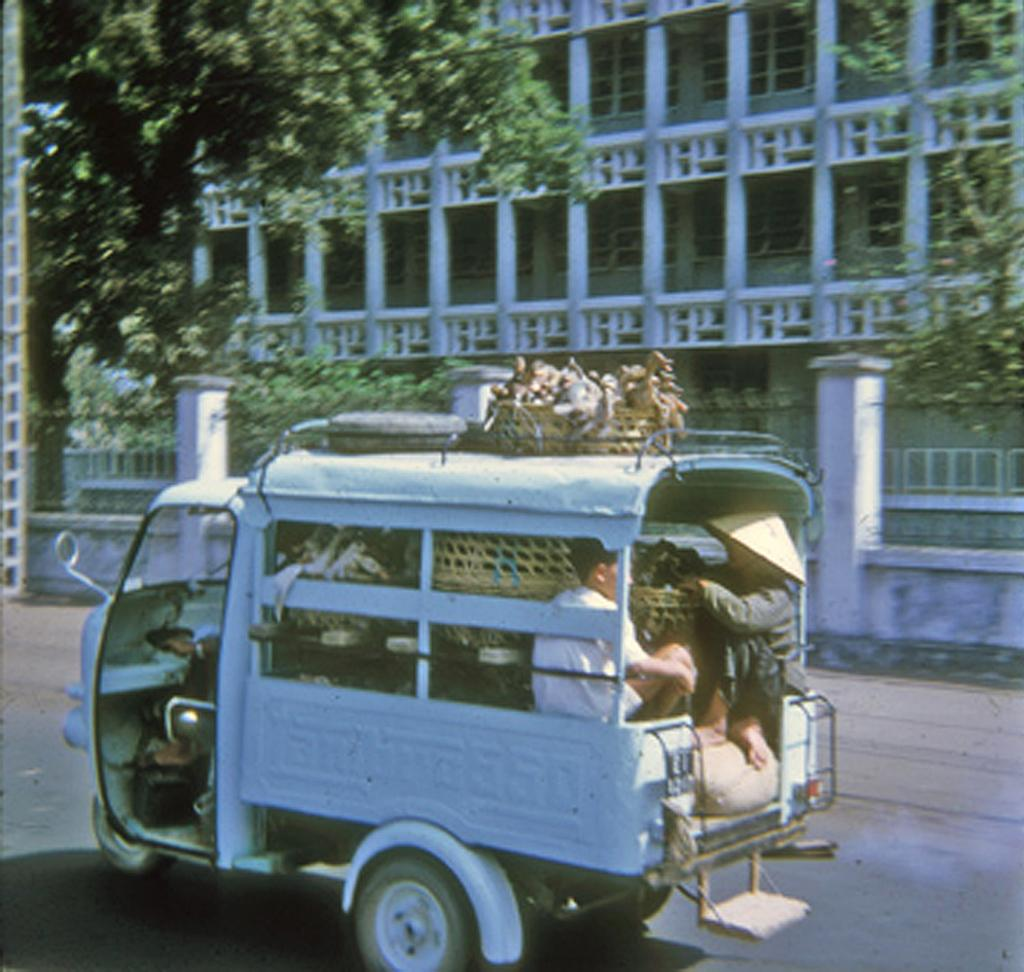What is happening in the image? There are people in a vehicle in the image. What can be seen inside the vehicle? There are objects in the vehicle. What is visible outside the vehicle? The road is visible in the image. What can be seen in the distance in the image? There is a building and trees in the background of the image. What else can be seen in the background of the image? There are windows in the background of the image. What type of paper is being used to take the picture in the image? There is no camera or paper present in the image; it is a still image of people in a vehicle. 